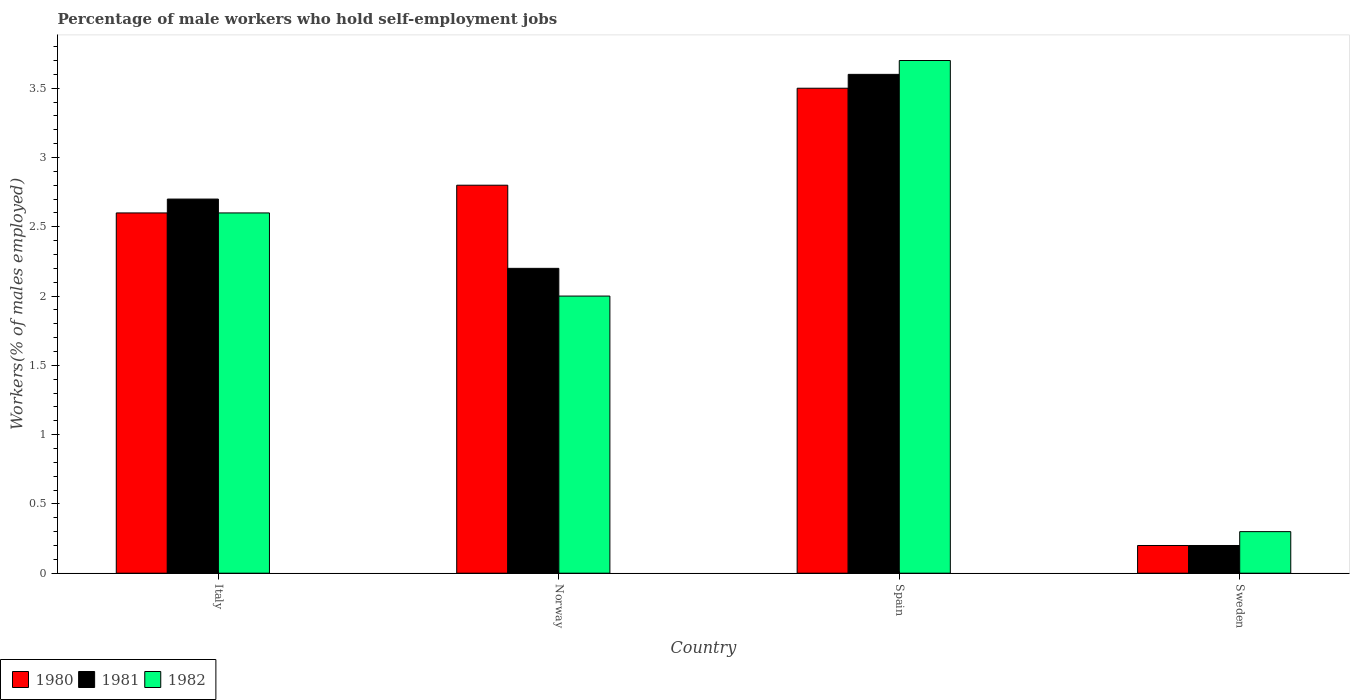How many groups of bars are there?
Provide a succinct answer. 4. Are the number of bars per tick equal to the number of legend labels?
Provide a succinct answer. Yes. Are the number of bars on each tick of the X-axis equal?
Offer a terse response. Yes. How many bars are there on the 1st tick from the right?
Provide a short and direct response. 3. What is the label of the 1st group of bars from the left?
Provide a succinct answer. Italy. What is the percentage of self-employed male workers in 1982 in Spain?
Give a very brief answer. 3.7. Across all countries, what is the maximum percentage of self-employed male workers in 1981?
Give a very brief answer. 3.6. Across all countries, what is the minimum percentage of self-employed male workers in 1981?
Your answer should be compact. 0.2. What is the total percentage of self-employed male workers in 1982 in the graph?
Your answer should be very brief. 8.6. What is the difference between the percentage of self-employed male workers in 1981 in Norway and that in Sweden?
Provide a succinct answer. 2. What is the difference between the percentage of self-employed male workers in 1980 in Spain and the percentage of self-employed male workers in 1982 in Italy?
Give a very brief answer. 0.9. What is the average percentage of self-employed male workers in 1981 per country?
Ensure brevity in your answer.  2.18. What is the difference between the percentage of self-employed male workers of/in 1982 and percentage of self-employed male workers of/in 1980 in Norway?
Give a very brief answer. -0.8. What is the ratio of the percentage of self-employed male workers in 1980 in Italy to that in Norway?
Keep it short and to the point. 0.93. Is the percentage of self-employed male workers in 1981 in Italy less than that in Norway?
Your answer should be compact. No. What is the difference between the highest and the second highest percentage of self-employed male workers in 1981?
Offer a very short reply. -0.5. What is the difference between the highest and the lowest percentage of self-employed male workers in 1980?
Give a very brief answer. 3.3. In how many countries, is the percentage of self-employed male workers in 1980 greater than the average percentage of self-employed male workers in 1980 taken over all countries?
Give a very brief answer. 3. How many bars are there?
Your answer should be compact. 12. Are all the bars in the graph horizontal?
Provide a short and direct response. No. Are the values on the major ticks of Y-axis written in scientific E-notation?
Offer a terse response. No. Does the graph contain any zero values?
Offer a very short reply. No. Where does the legend appear in the graph?
Offer a terse response. Bottom left. What is the title of the graph?
Give a very brief answer. Percentage of male workers who hold self-employment jobs. Does "1962" appear as one of the legend labels in the graph?
Provide a short and direct response. No. What is the label or title of the Y-axis?
Give a very brief answer. Workers(% of males employed). What is the Workers(% of males employed) of 1980 in Italy?
Offer a very short reply. 2.6. What is the Workers(% of males employed) in 1981 in Italy?
Offer a terse response. 2.7. What is the Workers(% of males employed) in 1982 in Italy?
Your response must be concise. 2.6. What is the Workers(% of males employed) of 1980 in Norway?
Your answer should be very brief. 2.8. What is the Workers(% of males employed) in 1981 in Norway?
Your response must be concise. 2.2. What is the Workers(% of males employed) of 1981 in Spain?
Provide a short and direct response. 3.6. What is the Workers(% of males employed) of 1982 in Spain?
Your answer should be very brief. 3.7. What is the Workers(% of males employed) in 1980 in Sweden?
Give a very brief answer. 0.2. What is the Workers(% of males employed) in 1981 in Sweden?
Provide a short and direct response. 0.2. What is the Workers(% of males employed) in 1982 in Sweden?
Offer a terse response. 0.3. Across all countries, what is the maximum Workers(% of males employed) of 1980?
Make the answer very short. 3.5. Across all countries, what is the maximum Workers(% of males employed) of 1981?
Provide a short and direct response. 3.6. Across all countries, what is the maximum Workers(% of males employed) in 1982?
Your answer should be compact. 3.7. Across all countries, what is the minimum Workers(% of males employed) of 1980?
Offer a terse response. 0.2. Across all countries, what is the minimum Workers(% of males employed) of 1981?
Offer a terse response. 0.2. Across all countries, what is the minimum Workers(% of males employed) of 1982?
Your answer should be very brief. 0.3. What is the total Workers(% of males employed) of 1980 in the graph?
Provide a succinct answer. 9.1. What is the total Workers(% of males employed) of 1982 in the graph?
Your response must be concise. 8.6. What is the difference between the Workers(% of males employed) in 1982 in Italy and that in Norway?
Make the answer very short. 0.6. What is the difference between the Workers(% of males employed) in 1980 in Italy and that in Spain?
Give a very brief answer. -0.9. What is the difference between the Workers(% of males employed) in 1980 in Italy and that in Sweden?
Keep it short and to the point. 2.4. What is the difference between the Workers(% of males employed) in 1982 in Italy and that in Sweden?
Make the answer very short. 2.3. What is the difference between the Workers(% of males employed) in 1982 in Norway and that in Spain?
Your answer should be compact. -1.7. What is the difference between the Workers(% of males employed) in 1980 in Norway and that in Sweden?
Provide a short and direct response. 2.6. What is the difference between the Workers(% of males employed) in 1981 in Norway and that in Sweden?
Ensure brevity in your answer.  2. What is the difference between the Workers(% of males employed) in 1980 in Spain and that in Sweden?
Offer a terse response. 3.3. What is the difference between the Workers(% of males employed) in 1982 in Spain and that in Sweden?
Provide a succinct answer. 3.4. What is the difference between the Workers(% of males employed) in 1980 in Italy and the Workers(% of males employed) in 1981 in Norway?
Provide a short and direct response. 0.4. What is the difference between the Workers(% of males employed) in 1980 in Italy and the Workers(% of males employed) in 1982 in Norway?
Your response must be concise. 0.6. What is the difference between the Workers(% of males employed) of 1981 in Italy and the Workers(% of males employed) of 1982 in Spain?
Your answer should be compact. -1. What is the difference between the Workers(% of males employed) of 1980 in Italy and the Workers(% of males employed) of 1981 in Sweden?
Give a very brief answer. 2.4. What is the difference between the Workers(% of males employed) of 1980 in Norway and the Workers(% of males employed) of 1981 in Spain?
Keep it short and to the point. -0.8. What is the difference between the Workers(% of males employed) of 1980 in Norway and the Workers(% of males employed) of 1982 in Spain?
Ensure brevity in your answer.  -0.9. What is the difference between the Workers(% of males employed) of 1981 in Norway and the Workers(% of males employed) of 1982 in Spain?
Provide a short and direct response. -1.5. What is the difference between the Workers(% of males employed) of 1980 in Norway and the Workers(% of males employed) of 1981 in Sweden?
Your response must be concise. 2.6. What is the difference between the Workers(% of males employed) of 1981 in Norway and the Workers(% of males employed) of 1982 in Sweden?
Ensure brevity in your answer.  1.9. What is the difference between the Workers(% of males employed) in 1980 in Spain and the Workers(% of males employed) in 1982 in Sweden?
Keep it short and to the point. 3.2. What is the average Workers(% of males employed) in 1980 per country?
Ensure brevity in your answer.  2.27. What is the average Workers(% of males employed) of 1981 per country?
Your answer should be very brief. 2.17. What is the average Workers(% of males employed) of 1982 per country?
Your answer should be compact. 2.15. What is the difference between the Workers(% of males employed) in 1980 and Workers(% of males employed) in 1982 in Italy?
Your answer should be compact. 0. What is the difference between the Workers(% of males employed) of 1981 and Workers(% of males employed) of 1982 in Italy?
Give a very brief answer. 0.1. What is the difference between the Workers(% of males employed) in 1980 and Workers(% of males employed) in 1981 in Norway?
Offer a terse response. 0.6. What is the difference between the Workers(% of males employed) of 1981 and Workers(% of males employed) of 1982 in Norway?
Make the answer very short. 0.2. What is the difference between the Workers(% of males employed) of 1981 and Workers(% of males employed) of 1982 in Spain?
Your answer should be compact. -0.1. What is the difference between the Workers(% of males employed) in 1980 and Workers(% of males employed) in 1982 in Sweden?
Provide a short and direct response. -0.1. What is the difference between the Workers(% of males employed) in 1981 and Workers(% of males employed) in 1982 in Sweden?
Your response must be concise. -0.1. What is the ratio of the Workers(% of males employed) of 1980 in Italy to that in Norway?
Offer a terse response. 0.93. What is the ratio of the Workers(% of males employed) in 1981 in Italy to that in Norway?
Your answer should be very brief. 1.23. What is the ratio of the Workers(% of males employed) in 1982 in Italy to that in Norway?
Provide a succinct answer. 1.3. What is the ratio of the Workers(% of males employed) in 1980 in Italy to that in Spain?
Provide a succinct answer. 0.74. What is the ratio of the Workers(% of males employed) of 1981 in Italy to that in Spain?
Your answer should be compact. 0.75. What is the ratio of the Workers(% of males employed) of 1982 in Italy to that in Spain?
Provide a succinct answer. 0.7. What is the ratio of the Workers(% of males employed) of 1981 in Italy to that in Sweden?
Your answer should be very brief. 13.5. What is the ratio of the Workers(% of males employed) in 1982 in Italy to that in Sweden?
Offer a terse response. 8.67. What is the ratio of the Workers(% of males employed) in 1981 in Norway to that in Spain?
Your response must be concise. 0.61. What is the ratio of the Workers(% of males employed) of 1982 in Norway to that in Spain?
Keep it short and to the point. 0.54. What is the ratio of the Workers(% of males employed) of 1980 in Norway to that in Sweden?
Ensure brevity in your answer.  14. What is the ratio of the Workers(% of males employed) of 1982 in Norway to that in Sweden?
Ensure brevity in your answer.  6.67. What is the ratio of the Workers(% of males employed) in 1980 in Spain to that in Sweden?
Offer a terse response. 17.5. What is the ratio of the Workers(% of males employed) of 1982 in Spain to that in Sweden?
Give a very brief answer. 12.33. What is the difference between the highest and the second highest Workers(% of males employed) in 1980?
Offer a very short reply. 0.7. What is the difference between the highest and the second highest Workers(% of males employed) of 1982?
Keep it short and to the point. 1.1. What is the difference between the highest and the lowest Workers(% of males employed) in 1980?
Your answer should be compact. 3.3. 